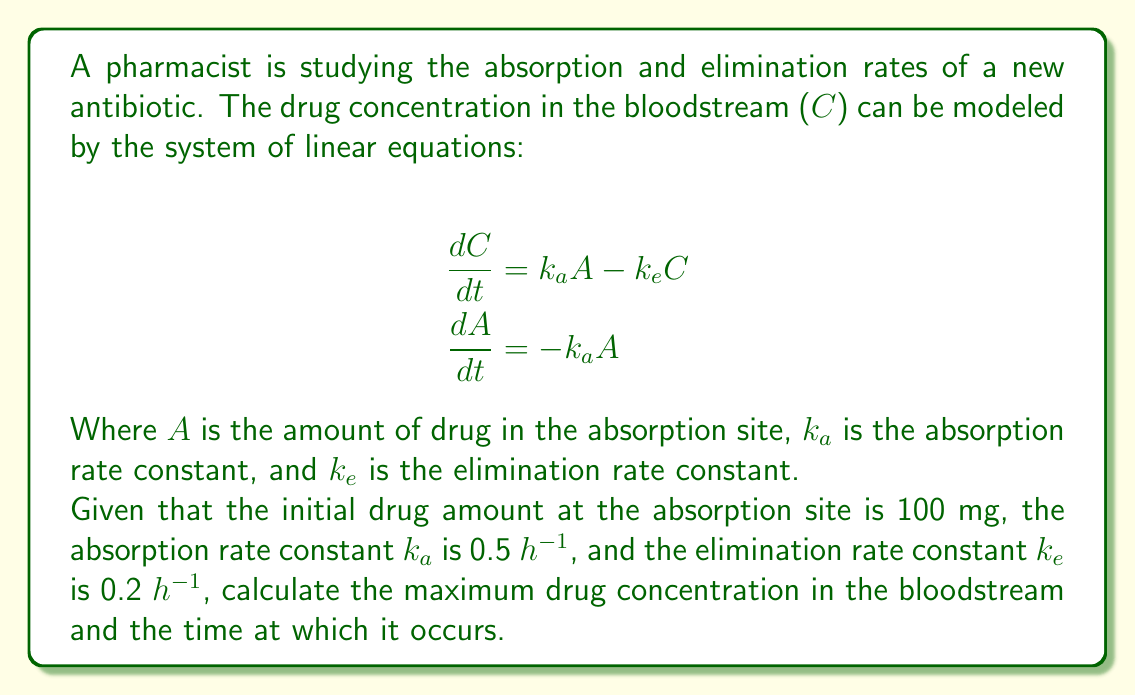What is the answer to this math problem? To solve this problem, we need to follow these steps:

1) First, we solve the second equation:
   $$\frac{dA}{dt} = -k_a A$$
   This is a separable differential equation. Solving it gives:
   $$A(t) = A_0 e^{-k_a t}$$
   Where $A_0 = 100$ mg (initial amount at absorption site)

2) Now, we substitute this into the first equation:
   $$\frac{dC}{dt} = k_a (100 e^{-k_a t}) - k_e C$$

3) This is a linear first-order differential equation. The general solution is:
   $$C(t) = \frac{100 k_a}{k_e - k_a} (e^{-k_a t} - e^{-k_e t})$$

4) To find the maximum concentration, we differentiate $C(t)$ and set it to zero:
   $$\frac{dC}{dt} = \frac{100 k_a}{k_e - k_a} (-k_a e^{-k_a t} + k_e e^{-k_e t}) = 0$$

5) Solving this equation:
   $$k_e e^{-k_e t} = k_a e^{-k_a t}$$
   $$t = \frac{\ln(k_e/k_a)}{k_e - k_a}$$

6) Substituting the given values $k_a = 0.5$ and $k_e = 0.2$:
   $$t = \frac{\ln(0.2/0.5)}{0.2 - 0.5} = 2.47 \text{ hours}$$

7) The maximum concentration is found by plugging this time back into the equation for $C(t)$:
   $$C_{max} = \frac{100 \cdot 0.5}{0.2 - 0.5} (e^{-0.5 \cdot 2.47} - e^{-0.2 \cdot 2.47}) = 36.79 \text{ mg/L}$$
Answer: The maximum drug concentration in the bloodstream is approximately 36.79 mg/L, occurring at 2.47 hours after administration. 